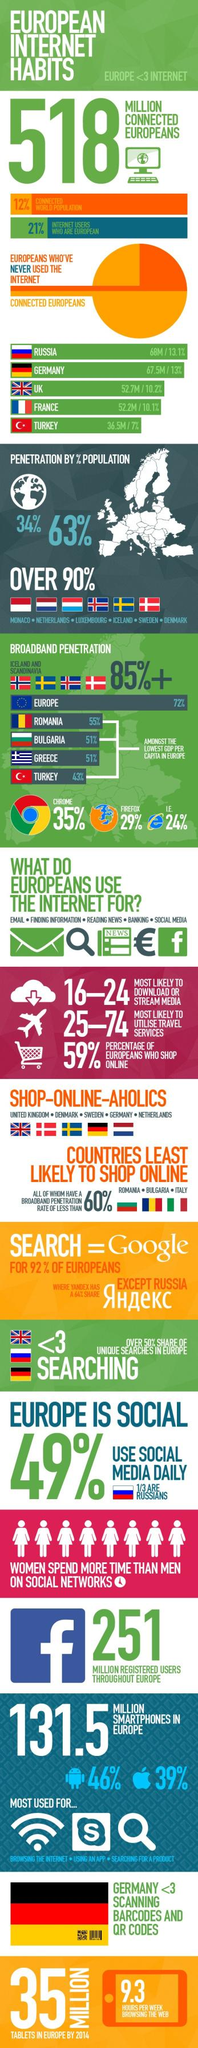Mention a couple of crucial points in this snapshot. A large number of countries utilize the internet to engage in online shopping, with the greatest number of such countries using it the most. According to a recent survey, 39% of users in Europe use Apple smartphones. The country with the third highest number of internet users is the United Kingdom. According to a recent study, a significant majority of internet users, approximately 79%, are not European. Four Scandinavian countries have been compared for broadband penetration. 